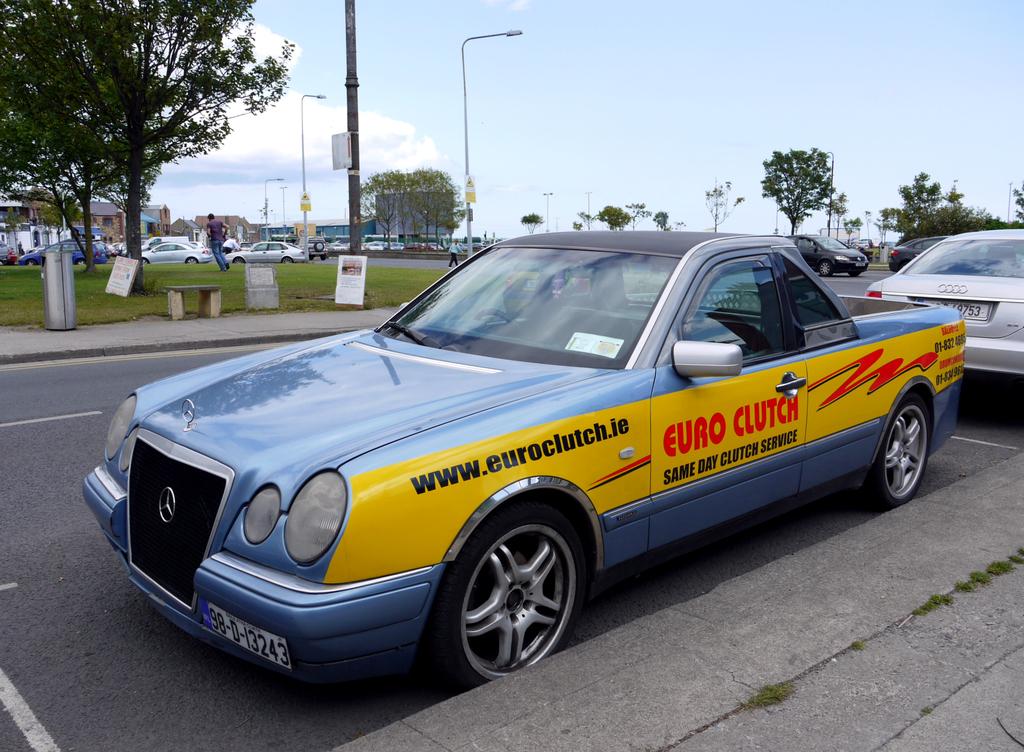What does the red text say?
Give a very brief answer. Euro clutch. What is the url on the car?
Give a very brief answer. Www.euroclutch.ie. 